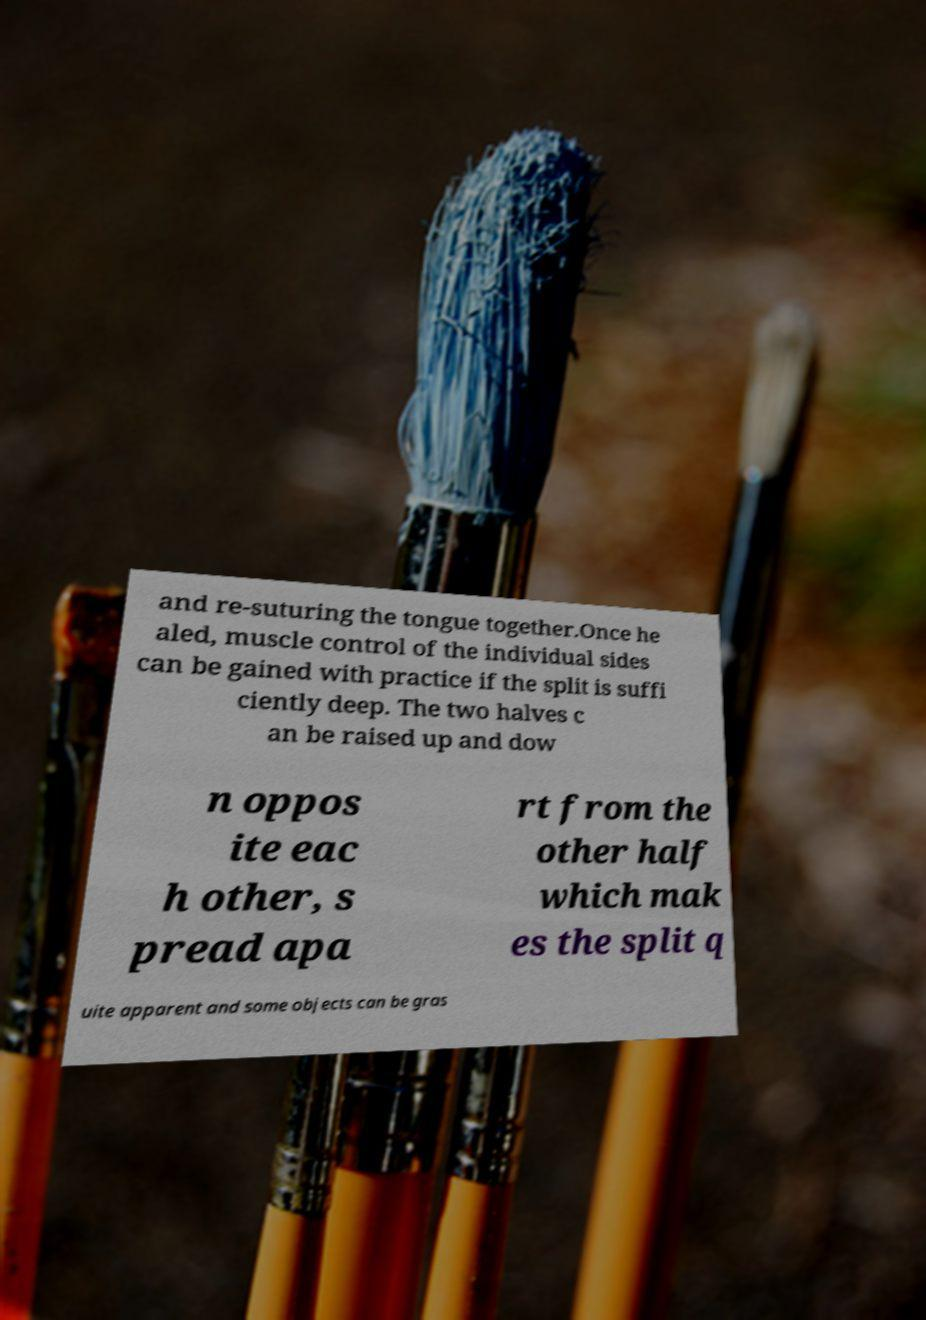Could you assist in decoding the text presented in this image and type it out clearly? and re-suturing the tongue together.Once he aled, muscle control of the individual sides can be gained with practice if the split is suffi ciently deep. The two halves c an be raised up and dow n oppos ite eac h other, s pread apa rt from the other half which mak es the split q uite apparent and some objects can be gras 